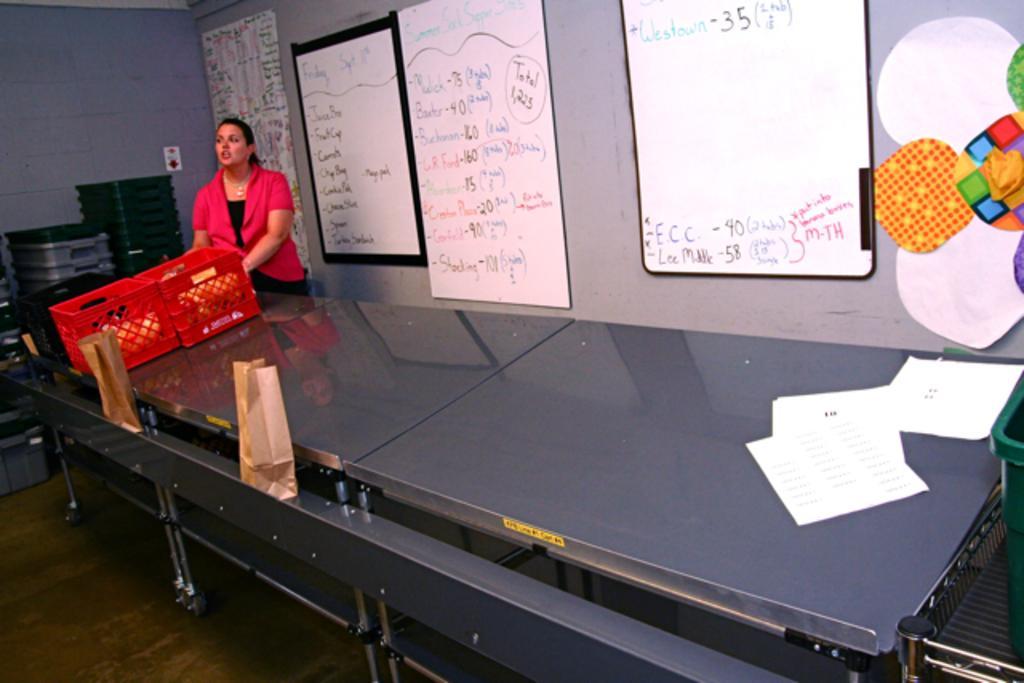Could you give a brief overview of what you see in this image? On the background we can see wall and board over a wall. Here we can see one woman standing in front of a table and on the table we can see two red containers, papers. This is a floor. Here we can see few empty containers. 